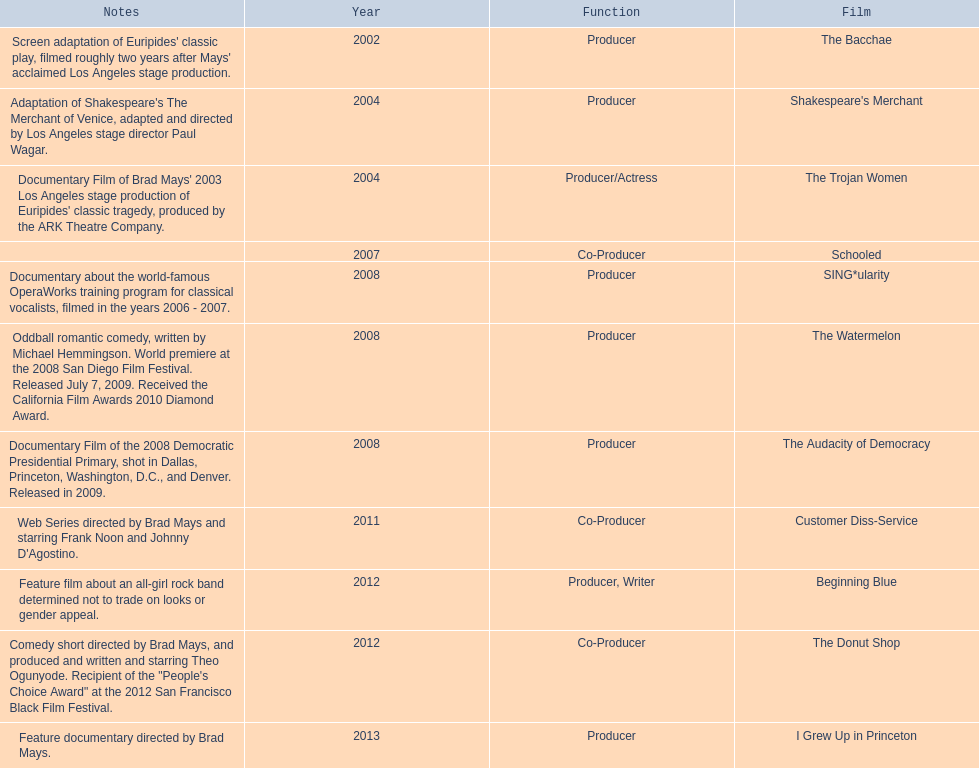How many years before was the film bacchae out before the watermelon? 6. 